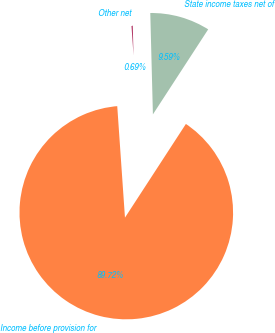Convert chart to OTSL. <chart><loc_0><loc_0><loc_500><loc_500><pie_chart><fcel>Income before provision for<fcel>State income taxes net of<fcel>Other net<nl><fcel>89.72%<fcel>9.59%<fcel>0.69%<nl></chart> 